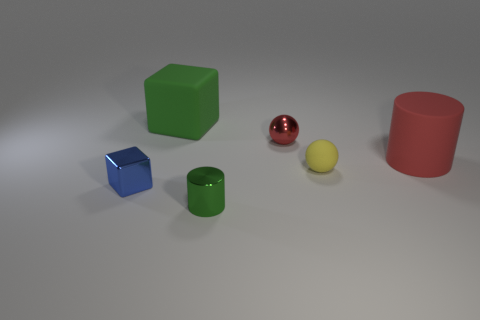Add 3 red shiny things. How many objects exist? 9 Subtract all large rubber cylinders. Subtract all yellow matte objects. How many objects are left? 4 Add 5 tiny blue metal objects. How many tiny blue metal objects are left? 6 Add 1 tiny gray cylinders. How many tiny gray cylinders exist? 1 Subtract 0 green balls. How many objects are left? 6 Subtract all balls. How many objects are left? 4 